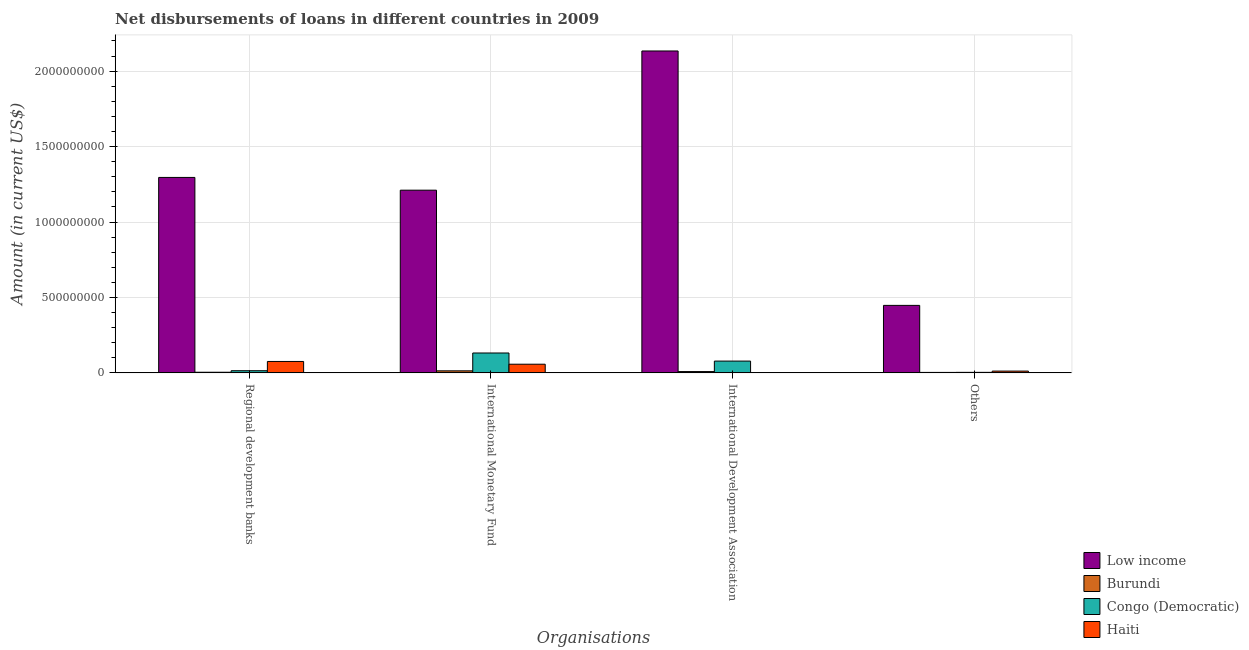How many different coloured bars are there?
Keep it short and to the point. 4. Are the number of bars per tick equal to the number of legend labels?
Make the answer very short. No. How many bars are there on the 4th tick from the left?
Offer a terse response. 4. How many bars are there on the 3rd tick from the right?
Ensure brevity in your answer.  4. What is the label of the 3rd group of bars from the left?
Your answer should be very brief. International Development Association. What is the amount of loan disimbursed by international development association in Low income?
Your answer should be compact. 2.13e+09. Across all countries, what is the maximum amount of loan disimbursed by other organisations?
Your response must be concise. 4.47e+08. Across all countries, what is the minimum amount of loan disimbursed by international monetary fund?
Your answer should be compact. 1.34e+07. In which country was the amount of loan disimbursed by regional development banks maximum?
Make the answer very short. Low income. What is the total amount of loan disimbursed by regional development banks in the graph?
Make the answer very short. 1.39e+09. What is the difference between the amount of loan disimbursed by international monetary fund in Congo (Democratic) and that in Low income?
Give a very brief answer. -1.08e+09. What is the difference between the amount of loan disimbursed by other organisations in Burundi and the amount of loan disimbursed by international development association in Haiti?
Give a very brief answer. 3.04e+06. What is the average amount of loan disimbursed by other organisations per country?
Make the answer very short. 1.16e+08. What is the difference between the amount of loan disimbursed by international monetary fund and amount of loan disimbursed by regional development banks in Congo (Democratic)?
Ensure brevity in your answer.  1.17e+08. In how many countries, is the amount of loan disimbursed by international development association greater than 700000000 US$?
Ensure brevity in your answer.  1. What is the ratio of the amount of loan disimbursed by international monetary fund in Congo (Democratic) to that in Low income?
Offer a terse response. 0.11. What is the difference between the highest and the second highest amount of loan disimbursed by regional development banks?
Ensure brevity in your answer.  1.22e+09. What is the difference between the highest and the lowest amount of loan disimbursed by other organisations?
Offer a terse response. 4.44e+08. Is the sum of the amount of loan disimbursed by other organisations in Burundi and Low income greater than the maximum amount of loan disimbursed by international monetary fund across all countries?
Offer a terse response. No. Is it the case that in every country, the sum of the amount of loan disimbursed by regional development banks and amount of loan disimbursed by other organisations is greater than the sum of amount of loan disimbursed by international monetary fund and amount of loan disimbursed by international development association?
Give a very brief answer. No. Is it the case that in every country, the sum of the amount of loan disimbursed by regional development banks and amount of loan disimbursed by international monetary fund is greater than the amount of loan disimbursed by international development association?
Your answer should be very brief. Yes. How many bars are there?
Provide a succinct answer. 15. Are all the bars in the graph horizontal?
Provide a succinct answer. No. How many countries are there in the graph?
Keep it short and to the point. 4. What is the difference between two consecutive major ticks on the Y-axis?
Make the answer very short. 5.00e+08. Does the graph contain any zero values?
Make the answer very short. Yes. Does the graph contain grids?
Your answer should be compact. Yes. How many legend labels are there?
Provide a short and direct response. 4. What is the title of the graph?
Make the answer very short. Net disbursements of loans in different countries in 2009. Does "Sint Maarten (Dutch part)" appear as one of the legend labels in the graph?
Offer a terse response. No. What is the label or title of the X-axis?
Your answer should be compact. Organisations. What is the label or title of the Y-axis?
Offer a very short reply. Amount (in current US$). What is the Amount (in current US$) in Low income in Regional development banks?
Ensure brevity in your answer.  1.30e+09. What is the Amount (in current US$) of Burundi in Regional development banks?
Provide a short and direct response. 4.18e+06. What is the Amount (in current US$) in Congo (Democratic) in Regional development banks?
Offer a very short reply. 1.43e+07. What is the Amount (in current US$) in Haiti in Regional development banks?
Your response must be concise. 7.56e+07. What is the Amount (in current US$) of Low income in International Monetary Fund?
Offer a terse response. 1.21e+09. What is the Amount (in current US$) of Burundi in International Monetary Fund?
Offer a terse response. 1.34e+07. What is the Amount (in current US$) of Congo (Democratic) in International Monetary Fund?
Your answer should be very brief. 1.32e+08. What is the Amount (in current US$) of Haiti in International Monetary Fund?
Provide a succinct answer. 5.74e+07. What is the Amount (in current US$) in Low income in International Development Association?
Your answer should be compact. 2.13e+09. What is the Amount (in current US$) in Burundi in International Development Association?
Offer a very short reply. 8.56e+06. What is the Amount (in current US$) in Congo (Democratic) in International Development Association?
Keep it short and to the point. 7.81e+07. What is the Amount (in current US$) in Haiti in International Development Association?
Offer a terse response. 0. What is the Amount (in current US$) in Low income in Others?
Make the answer very short. 4.47e+08. What is the Amount (in current US$) of Burundi in Others?
Your answer should be very brief. 3.04e+06. What is the Amount (in current US$) in Congo (Democratic) in Others?
Provide a short and direct response. 3.45e+06. What is the Amount (in current US$) in Haiti in Others?
Ensure brevity in your answer.  1.18e+07. Across all Organisations, what is the maximum Amount (in current US$) in Low income?
Keep it short and to the point. 2.13e+09. Across all Organisations, what is the maximum Amount (in current US$) of Burundi?
Keep it short and to the point. 1.34e+07. Across all Organisations, what is the maximum Amount (in current US$) in Congo (Democratic)?
Provide a short and direct response. 1.32e+08. Across all Organisations, what is the maximum Amount (in current US$) in Haiti?
Your answer should be compact. 7.56e+07. Across all Organisations, what is the minimum Amount (in current US$) in Low income?
Your answer should be compact. 4.47e+08. Across all Organisations, what is the minimum Amount (in current US$) of Burundi?
Keep it short and to the point. 3.04e+06. Across all Organisations, what is the minimum Amount (in current US$) in Congo (Democratic)?
Keep it short and to the point. 3.45e+06. What is the total Amount (in current US$) in Low income in the graph?
Give a very brief answer. 5.09e+09. What is the total Amount (in current US$) of Burundi in the graph?
Ensure brevity in your answer.  2.92e+07. What is the total Amount (in current US$) of Congo (Democratic) in the graph?
Give a very brief answer. 2.28e+08. What is the total Amount (in current US$) in Haiti in the graph?
Your answer should be very brief. 1.45e+08. What is the difference between the Amount (in current US$) of Low income in Regional development banks and that in International Monetary Fund?
Your response must be concise. 8.45e+07. What is the difference between the Amount (in current US$) of Burundi in Regional development banks and that in International Monetary Fund?
Your response must be concise. -9.24e+06. What is the difference between the Amount (in current US$) of Congo (Democratic) in Regional development banks and that in International Monetary Fund?
Provide a short and direct response. -1.17e+08. What is the difference between the Amount (in current US$) in Haiti in Regional development banks and that in International Monetary Fund?
Your answer should be very brief. 1.82e+07. What is the difference between the Amount (in current US$) in Low income in Regional development banks and that in International Development Association?
Offer a terse response. -8.38e+08. What is the difference between the Amount (in current US$) in Burundi in Regional development banks and that in International Development Association?
Provide a short and direct response. -4.38e+06. What is the difference between the Amount (in current US$) in Congo (Democratic) in Regional development banks and that in International Development Association?
Offer a very short reply. -6.38e+07. What is the difference between the Amount (in current US$) of Low income in Regional development banks and that in Others?
Give a very brief answer. 8.48e+08. What is the difference between the Amount (in current US$) of Burundi in Regional development banks and that in Others?
Offer a very short reply. 1.14e+06. What is the difference between the Amount (in current US$) in Congo (Democratic) in Regional development banks and that in Others?
Provide a succinct answer. 1.08e+07. What is the difference between the Amount (in current US$) of Haiti in Regional development banks and that in Others?
Provide a succinct answer. 6.38e+07. What is the difference between the Amount (in current US$) in Low income in International Monetary Fund and that in International Development Association?
Give a very brief answer. -9.23e+08. What is the difference between the Amount (in current US$) in Burundi in International Monetary Fund and that in International Development Association?
Keep it short and to the point. 4.86e+06. What is the difference between the Amount (in current US$) of Congo (Democratic) in International Monetary Fund and that in International Development Association?
Your answer should be compact. 5.36e+07. What is the difference between the Amount (in current US$) in Low income in International Monetary Fund and that in Others?
Make the answer very short. 7.64e+08. What is the difference between the Amount (in current US$) of Burundi in International Monetary Fund and that in Others?
Your response must be concise. 1.04e+07. What is the difference between the Amount (in current US$) of Congo (Democratic) in International Monetary Fund and that in Others?
Your answer should be compact. 1.28e+08. What is the difference between the Amount (in current US$) in Haiti in International Monetary Fund and that in Others?
Your answer should be very brief. 4.56e+07. What is the difference between the Amount (in current US$) of Low income in International Development Association and that in Others?
Offer a terse response. 1.69e+09. What is the difference between the Amount (in current US$) of Burundi in International Development Association and that in Others?
Offer a terse response. 5.51e+06. What is the difference between the Amount (in current US$) of Congo (Democratic) in International Development Association and that in Others?
Ensure brevity in your answer.  7.47e+07. What is the difference between the Amount (in current US$) of Low income in Regional development banks and the Amount (in current US$) of Burundi in International Monetary Fund?
Provide a short and direct response. 1.28e+09. What is the difference between the Amount (in current US$) in Low income in Regional development banks and the Amount (in current US$) in Congo (Democratic) in International Monetary Fund?
Make the answer very short. 1.16e+09. What is the difference between the Amount (in current US$) in Low income in Regional development banks and the Amount (in current US$) in Haiti in International Monetary Fund?
Your response must be concise. 1.24e+09. What is the difference between the Amount (in current US$) in Burundi in Regional development banks and the Amount (in current US$) in Congo (Democratic) in International Monetary Fund?
Offer a very short reply. -1.28e+08. What is the difference between the Amount (in current US$) of Burundi in Regional development banks and the Amount (in current US$) of Haiti in International Monetary Fund?
Keep it short and to the point. -5.32e+07. What is the difference between the Amount (in current US$) in Congo (Democratic) in Regional development banks and the Amount (in current US$) in Haiti in International Monetary Fund?
Give a very brief answer. -4.31e+07. What is the difference between the Amount (in current US$) in Low income in Regional development banks and the Amount (in current US$) in Burundi in International Development Association?
Provide a short and direct response. 1.29e+09. What is the difference between the Amount (in current US$) in Low income in Regional development banks and the Amount (in current US$) in Congo (Democratic) in International Development Association?
Offer a terse response. 1.22e+09. What is the difference between the Amount (in current US$) of Burundi in Regional development banks and the Amount (in current US$) of Congo (Democratic) in International Development Association?
Offer a very short reply. -7.40e+07. What is the difference between the Amount (in current US$) of Low income in Regional development banks and the Amount (in current US$) of Burundi in Others?
Offer a very short reply. 1.29e+09. What is the difference between the Amount (in current US$) of Low income in Regional development banks and the Amount (in current US$) of Congo (Democratic) in Others?
Your answer should be compact. 1.29e+09. What is the difference between the Amount (in current US$) in Low income in Regional development banks and the Amount (in current US$) in Haiti in Others?
Give a very brief answer. 1.28e+09. What is the difference between the Amount (in current US$) of Burundi in Regional development banks and the Amount (in current US$) of Congo (Democratic) in Others?
Keep it short and to the point. 7.29e+05. What is the difference between the Amount (in current US$) of Burundi in Regional development banks and the Amount (in current US$) of Haiti in Others?
Make the answer very short. -7.62e+06. What is the difference between the Amount (in current US$) of Congo (Democratic) in Regional development banks and the Amount (in current US$) of Haiti in Others?
Provide a short and direct response. 2.50e+06. What is the difference between the Amount (in current US$) in Low income in International Monetary Fund and the Amount (in current US$) in Burundi in International Development Association?
Give a very brief answer. 1.20e+09. What is the difference between the Amount (in current US$) of Low income in International Monetary Fund and the Amount (in current US$) of Congo (Democratic) in International Development Association?
Keep it short and to the point. 1.13e+09. What is the difference between the Amount (in current US$) in Burundi in International Monetary Fund and the Amount (in current US$) in Congo (Democratic) in International Development Association?
Make the answer very short. -6.47e+07. What is the difference between the Amount (in current US$) in Low income in International Monetary Fund and the Amount (in current US$) in Burundi in Others?
Provide a succinct answer. 1.21e+09. What is the difference between the Amount (in current US$) in Low income in International Monetary Fund and the Amount (in current US$) in Congo (Democratic) in Others?
Keep it short and to the point. 1.21e+09. What is the difference between the Amount (in current US$) in Low income in International Monetary Fund and the Amount (in current US$) in Haiti in Others?
Provide a short and direct response. 1.20e+09. What is the difference between the Amount (in current US$) in Burundi in International Monetary Fund and the Amount (in current US$) in Congo (Democratic) in Others?
Provide a succinct answer. 9.97e+06. What is the difference between the Amount (in current US$) in Burundi in International Monetary Fund and the Amount (in current US$) in Haiti in Others?
Provide a short and direct response. 1.62e+06. What is the difference between the Amount (in current US$) of Congo (Democratic) in International Monetary Fund and the Amount (in current US$) of Haiti in Others?
Ensure brevity in your answer.  1.20e+08. What is the difference between the Amount (in current US$) in Low income in International Development Association and the Amount (in current US$) in Burundi in Others?
Ensure brevity in your answer.  2.13e+09. What is the difference between the Amount (in current US$) in Low income in International Development Association and the Amount (in current US$) in Congo (Democratic) in Others?
Your answer should be compact. 2.13e+09. What is the difference between the Amount (in current US$) in Low income in International Development Association and the Amount (in current US$) in Haiti in Others?
Your answer should be very brief. 2.12e+09. What is the difference between the Amount (in current US$) in Burundi in International Development Association and the Amount (in current US$) in Congo (Democratic) in Others?
Ensure brevity in your answer.  5.10e+06. What is the difference between the Amount (in current US$) of Burundi in International Development Association and the Amount (in current US$) of Haiti in Others?
Offer a very short reply. -3.24e+06. What is the difference between the Amount (in current US$) in Congo (Democratic) in International Development Association and the Amount (in current US$) in Haiti in Others?
Your response must be concise. 6.63e+07. What is the average Amount (in current US$) of Low income per Organisations?
Provide a succinct answer. 1.27e+09. What is the average Amount (in current US$) in Burundi per Organisations?
Give a very brief answer. 7.30e+06. What is the average Amount (in current US$) of Congo (Democratic) per Organisations?
Provide a succinct answer. 5.69e+07. What is the average Amount (in current US$) in Haiti per Organisations?
Your answer should be compact. 3.62e+07. What is the difference between the Amount (in current US$) in Low income and Amount (in current US$) in Burundi in Regional development banks?
Give a very brief answer. 1.29e+09. What is the difference between the Amount (in current US$) of Low income and Amount (in current US$) of Congo (Democratic) in Regional development banks?
Offer a very short reply. 1.28e+09. What is the difference between the Amount (in current US$) in Low income and Amount (in current US$) in Haiti in Regional development banks?
Keep it short and to the point. 1.22e+09. What is the difference between the Amount (in current US$) in Burundi and Amount (in current US$) in Congo (Democratic) in Regional development banks?
Make the answer very short. -1.01e+07. What is the difference between the Amount (in current US$) in Burundi and Amount (in current US$) in Haiti in Regional development banks?
Provide a succinct answer. -7.14e+07. What is the difference between the Amount (in current US$) in Congo (Democratic) and Amount (in current US$) in Haiti in Regional development banks?
Offer a terse response. -6.13e+07. What is the difference between the Amount (in current US$) of Low income and Amount (in current US$) of Burundi in International Monetary Fund?
Your answer should be very brief. 1.20e+09. What is the difference between the Amount (in current US$) in Low income and Amount (in current US$) in Congo (Democratic) in International Monetary Fund?
Ensure brevity in your answer.  1.08e+09. What is the difference between the Amount (in current US$) in Low income and Amount (in current US$) in Haiti in International Monetary Fund?
Your response must be concise. 1.15e+09. What is the difference between the Amount (in current US$) of Burundi and Amount (in current US$) of Congo (Democratic) in International Monetary Fund?
Provide a succinct answer. -1.18e+08. What is the difference between the Amount (in current US$) of Burundi and Amount (in current US$) of Haiti in International Monetary Fund?
Keep it short and to the point. -4.40e+07. What is the difference between the Amount (in current US$) in Congo (Democratic) and Amount (in current US$) in Haiti in International Monetary Fund?
Provide a short and direct response. 7.43e+07. What is the difference between the Amount (in current US$) in Low income and Amount (in current US$) in Burundi in International Development Association?
Make the answer very short. 2.13e+09. What is the difference between the Amount (in current US$) of Low income and Amount (in current US$) of Congo (Democratic) in International Development Association?
Your answer should be compact. 2.06e+09. What is the difference between the Amount (in current US$) in Burundi and Amount (in current US$) in Congo (Democratic) in International Development Association?
Make the answer very short. -6.96e+07. What is the difference between the Amount (in current US$) in Low income and Amount (in current US$) in Burundi in Others?
Ensure brevity in your answer.  4.44e+08. What is the difference between the Amount (in current US$) of Low income and Amount (in current US$) of Congo (Democratic) in Others?
Provide a short and direct response. 4.44e+08. What is the difference between the Amount (in current US$) of Low income and Amount (in current US$) of Haiti in Others?
Ensure brevity in your answer.  4.36e+08. What is the difference between the Amount (in current US$) in Burundi and Amount (in current US$) in Congo (Democratic) in Others?
Your answer should be compact. -4.09e+05. What is the difference between the Amount (in current US$) in Burundi and Amount (in current US$) in Haiti in Others?
Make the answer very short. -8.76e+06. What is the difference between the Amount (in current US$) in Congo (Democratic) and Amount (in current US$) in Haiti in Others?
Provide a succinct answer. -8.35e+06. What is the ratio of the Amount (in current US$) in Low income in Regional development banks to that in International Monetary Fund?
Keep it short and to the point. 1.07. What is the ratio of the Amount (in current US$) of Burundi in Regional development banks to that in International Monetary Fund?
Keep it short and to the point. 0.31. What is the ratio of the Amount (in current US$) in Congo (Democratic) in Regional development banks to that in International Monetary Fund?
Offer a terse response. 0.11. What is the ratio of the Amount (in current US$) in Haiti in Regional development banks to that in International Monetary Fund?
Your answer should be very brief. 1.32. What is the ratio of the Amount (in current US$) of Low income in Regional development banks to that in International Development Association?
Provide a short and direct response. 0.61. What is the ratio of the Amount (in current US$) of Burundi in Regional development banks to that in International Development Association?
Offer a terse response. 0.49. What is the ratio of the Amount (in current US$) of Congo (Democratic) in Regional development banks to that in International Development Association?
Provide a succinct answer. 0.18. What is the ratio of the Amount (in current US$) in Low income in Regional development banks to that in Others?
Ensure brevity in your answer.  2.9. What is the ratio of the Amount (in current US$) of Burundi in Regional development banks to that in Others?
Ensure brevity in your answer.  1.37. What is the ratio of the Amount (in current US$) in Congo (Democratic) in Regional development banks to that in Others?
Give a very brief answer. 4.14. What is the ratio of the Amount (in current US$) of Haiti in Regional development banks to that in Others?
Offer a terse response. 6.4. What is the ratio of the Amount (in current US$) of Low income in International Monetary Fund to that in International Development Association?
Your answer should be compact. 0.57. What is the ratio of the Amount (in current US$) of Burundi in International Monetary Fund to that in International Development Association?
Give a very brief answer. 1.57. What is the ratio of the Amount (in current US$) of Congo (Democratic) in International Monetary Fund to that in International Development Association?
Offer a terse response. 1.69. What is the ratio of the Amount (in current US$) in Low income in International Monetary Fund to that in Others?
Make the answer very short. 2.71. What is the ratio of the Amount (in current US$) in Burundi in International Monetary Fund to that in Others?
Keep it short and to the point. 4.41. What is the ratio of the Amount (in current US$) of Congo (Democratic) in International Monetary Fund to that in Others?
Your response must be concise. 38.14. What is the ratio of the Amount (in current US$) of Haiti in International Monetary Fund to that in Others?
Your answer should be very brief. 4.86. What is the ratio of the Amount (in current US$) of Low income in International Development Association to that in Others?
Make the answer very short. 4.77. What is the ratio of the Amount (in current US$) in Burundi in International Development Association to that in Others?
Keep it short and to the point. 2.81. What is the ratio of the Amount (in current US$) in Congo (Democratic) in International Development Association to that in Others?
Offer a terse response. 22.62. What is the difference between the highest and the second highest Amount (in current US$) of Low income?
Provide a succinct answer. 8.38e+08. What is the difference between the highest and the second highest Amount (in current US$) in Burundi?
Your response must be concise. 4.86e+06. What is the difference between the highest and the second highest Amount (in current US$) of Congo (Democratic)?
Provide a succinct answer. 5.36e+07. What is the difference between the highest and the second highest Amount (in current US$) of Haiti?
Provide a short and direct response. 1.82e+07. What is the difference between the highest and the lowest Amount (in current US$) in Low income?
Make the answer very short. 1.69e+09. What is the difference between the highest and the lowest Amount (in current US$) in Burundi?
Keep it short and to the point. 1.04e+07. What is the difference between the highest and the lowest Amount (in current US$) of Congo (Democratic)?
Your answer should be compact. 1.28e+08. What is the difference between the highest and the lowest Amount (in current US$) of Haiti?
Keep it short and to the point. 7.56e+07. 